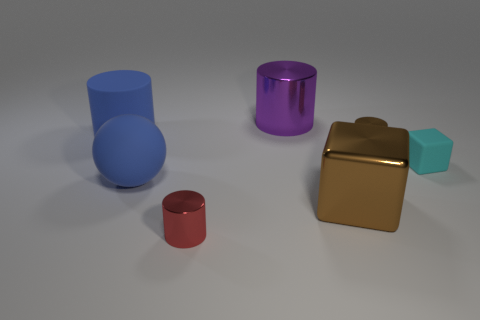Add 2 purple cylinders. How many objects exist? 9 Subtract all gray cylinders. Subtract all brown spheres. How many cylinders are left? 4 Subtract all spheres. How many objects are left? 6 Add 5 red cylinders. How many red cylinders are left? 6 Add 3 brown shiny things. How many brown shiny things exist? 5 Subtract 0 purple blocks. How many objects are left? 7 Subtract all green matte balls. Subtract all small brown metallic cylinders. How many objects are left? 6 